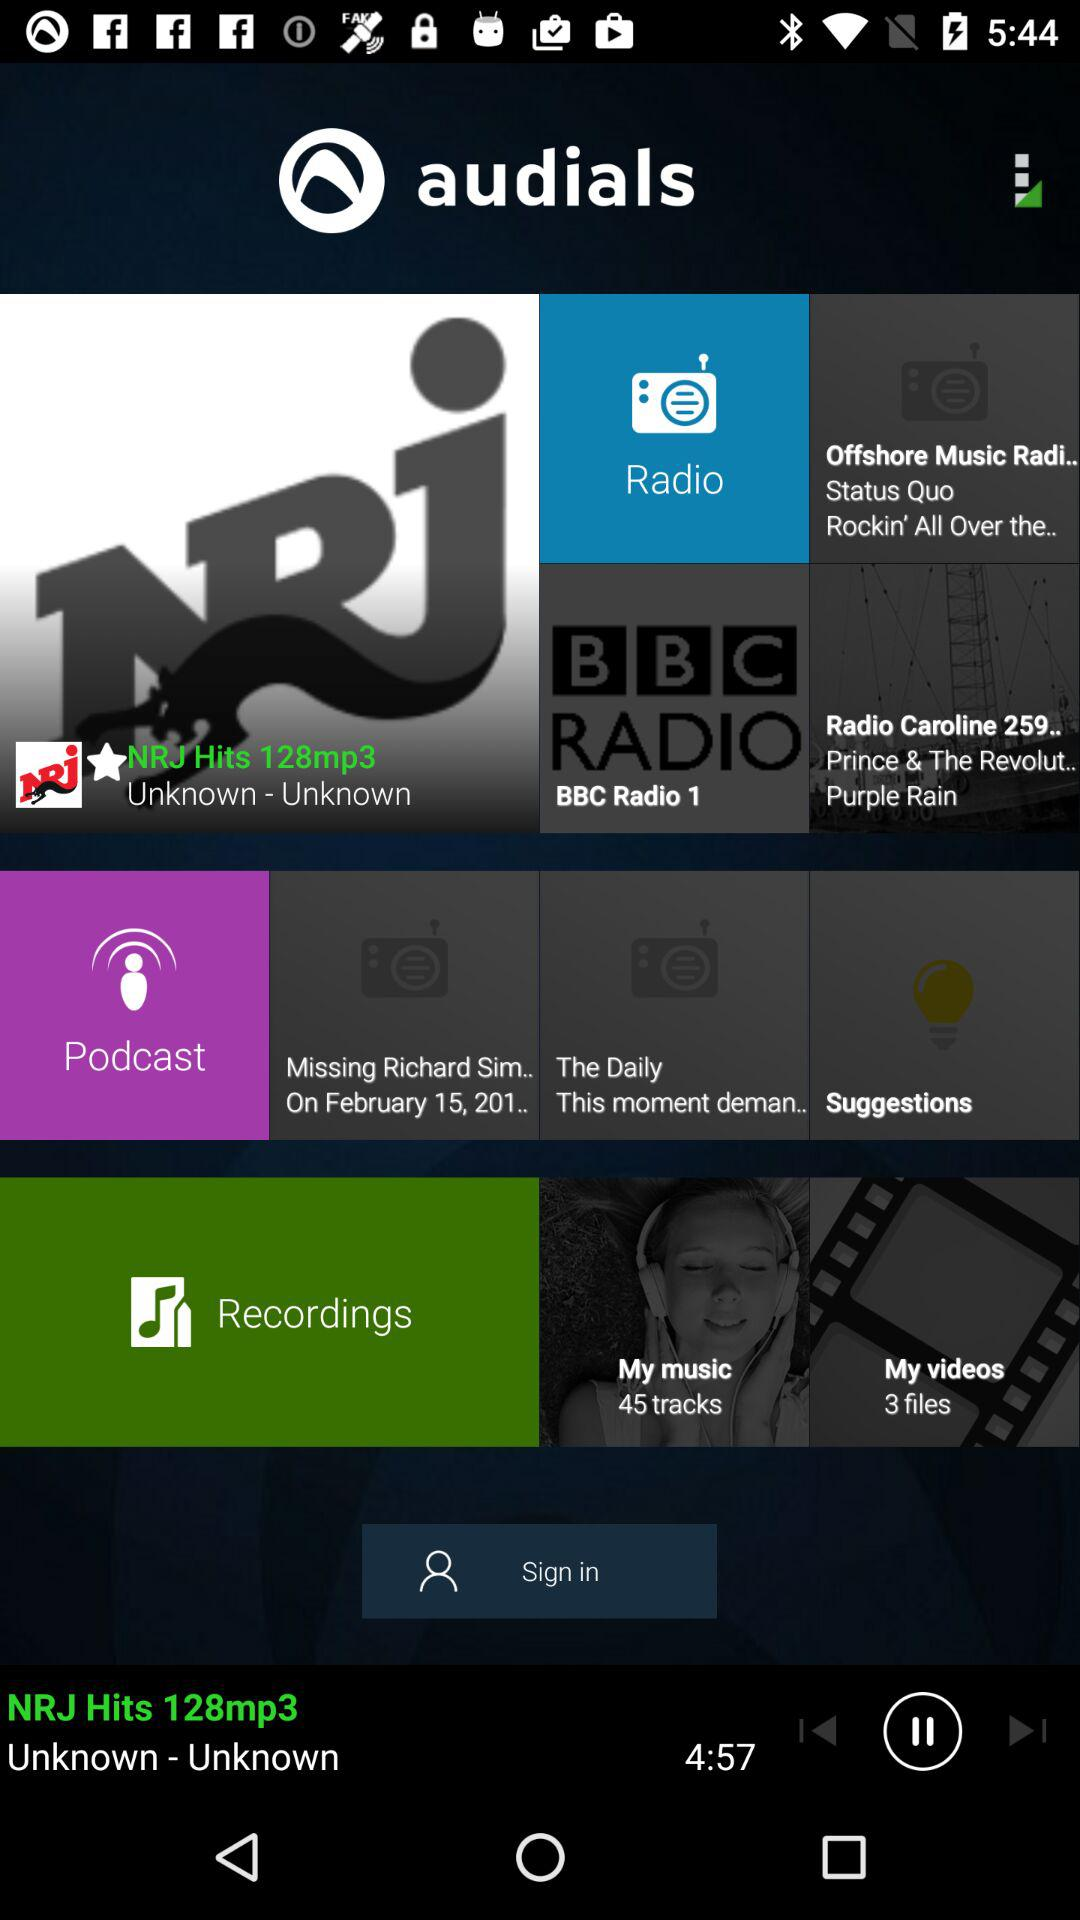How many tracks are present in "My music"? There are 45 tracks present in "My music". 